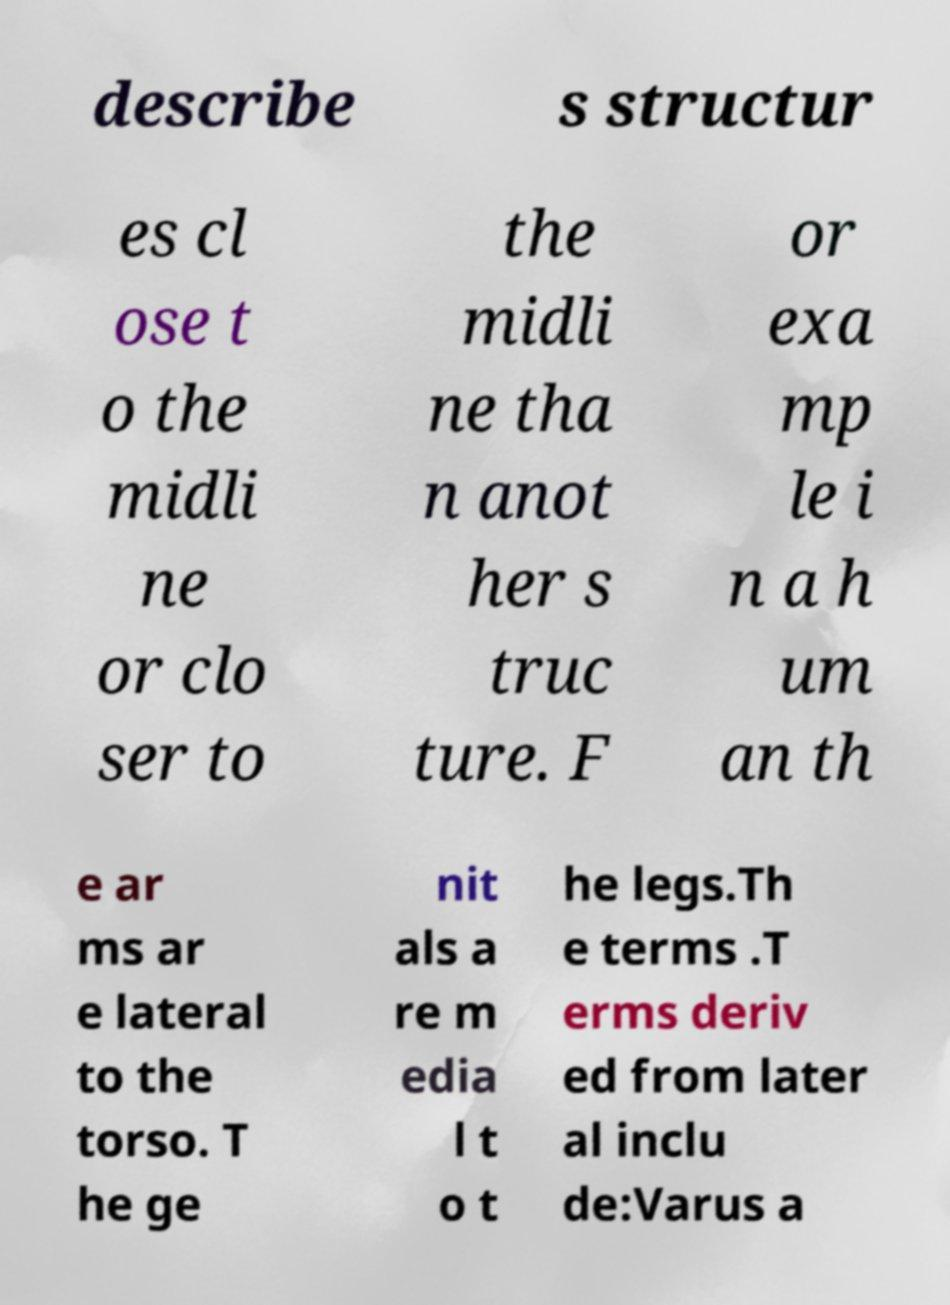Please identify and transcribe the text found in this image. describe s structur es cl ose t o the midli ne or clo ser to the midli ne tha n anot her s truc ture. F or exa mp le i n a h um an th e ar ms ar e lateral to the torso. T he ge nit als a re m edia l t o t he legs.Th e terms .T erms deriv ed from later al inclu de:Varus a 